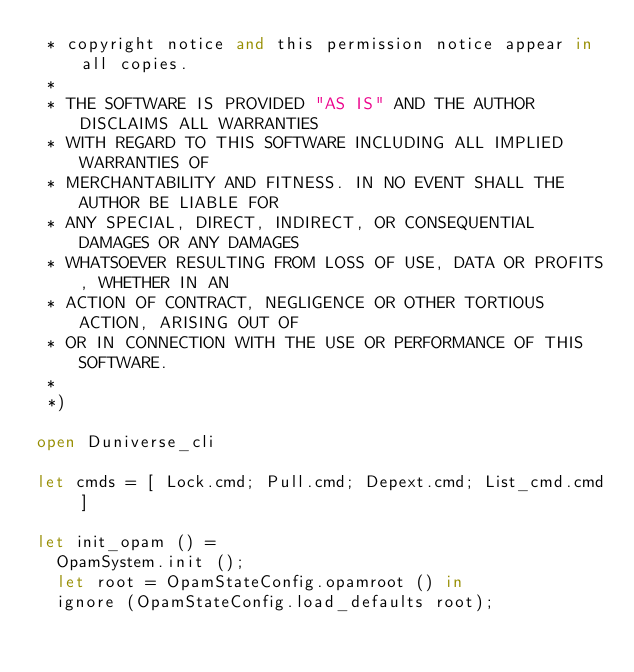Convert code to text. <code><loc_0><loc_0><loc_500><loc_500><_OCaml_> * copyright notice and this permission notice appear in all copies.
 *
 * THE SOFTWARE IS PROVIDED "AS IS" AND THE AUTHOR DISCLAIMS ALL WARRANTIES
 * WITH REGARD TO THIS SOFTWARE INCLUDING ALL IMPLIED WARRANTIES OF
 * MERCHANTABILITY AND FITNESS. IN NO EVENT SHALL THE AUTHOR BE LIABLE FOR
 * ANY SPECIAL, DIRECT, INDIRECT, OR CONSEQUENTIAL DAMAGES OR ANY DAMAGES
 * WHATSOEVER RESULTING FROM LOSS OF USE, DATA OR PROFITS, WHETHER IN AN
 * ACTION OF CONTRACT, NEGLIGENCE OR OTHER TORTIOUS ACTION, ARISING OUT OF
 * OR IN CONNECTION WITH THE USE OR PERFORMANCE OF THIS SOFTWARE.
 *
 *)

open Duniverse_cli

let cmds = [ Lock.cmd; Pull.cmd; Depext.cmd; List_cmd.cmd ]

let init_opam () =
  OpamSystem.init ();
  let root = OpamStateConfig.opamroot () in
  ignore (OpamStateConfig.load_defaults root);</code> 